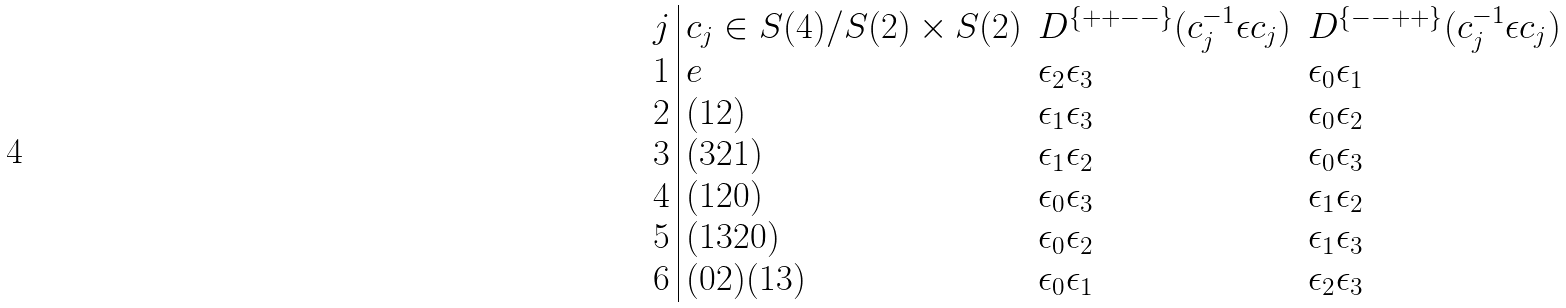<formula> <loc_0><loc_0><loc_500><loc_500>\begin{array} { l | l l l } j & c _ { j } \in S ( 4 ) / S ( 2 ) \times S ( 2 ) & D ^ { \{ + + - - \} } ( c _ { j } ^ { - 1 } \epsilon c _ { j } ) & D ^ { \{ - - + + \} } ( c _ { j } ^ { - 1 } \epsilon c _ { j } ) \\ 1 & e & \epsilon _ { 2 } \epsilon _ { 3 } & \epsilon _ { 0 } \epsilon _ { 1 } \\ 2 & ( 1 2 ) & \epsilon _ { 1 } \epsilon _ { 3 } & \epsilon _ { 0 } \epsilon _ { 2 } \\ 3 & ( 3 2 1 ) & \epsilon _ { 1 } \epsilon _ { 2 } & \epsilon _ { 0 } \epsilon _ { 3 } \\ 4 & ( 1 2 0 ) & \epsilon _ { 0 } \epsilon _ { 3 } & \epsilon _ { 1 } \epsilon _ { 2 } \\ 5 & ( 1 3 2 0 ) & \epsilon _ { 0 } \epsilon _ { 2 } & \epsilon _ { 1 } \epsilon _ { 3 } \\ 6 & ( 0 2 ) ( 1 3 ) & \epsilon _ { 0 } \epsilon _ { 1 } & \epsilon _ { 2 } \epsilon _ { 3 } \\ \end{array}</formula> 